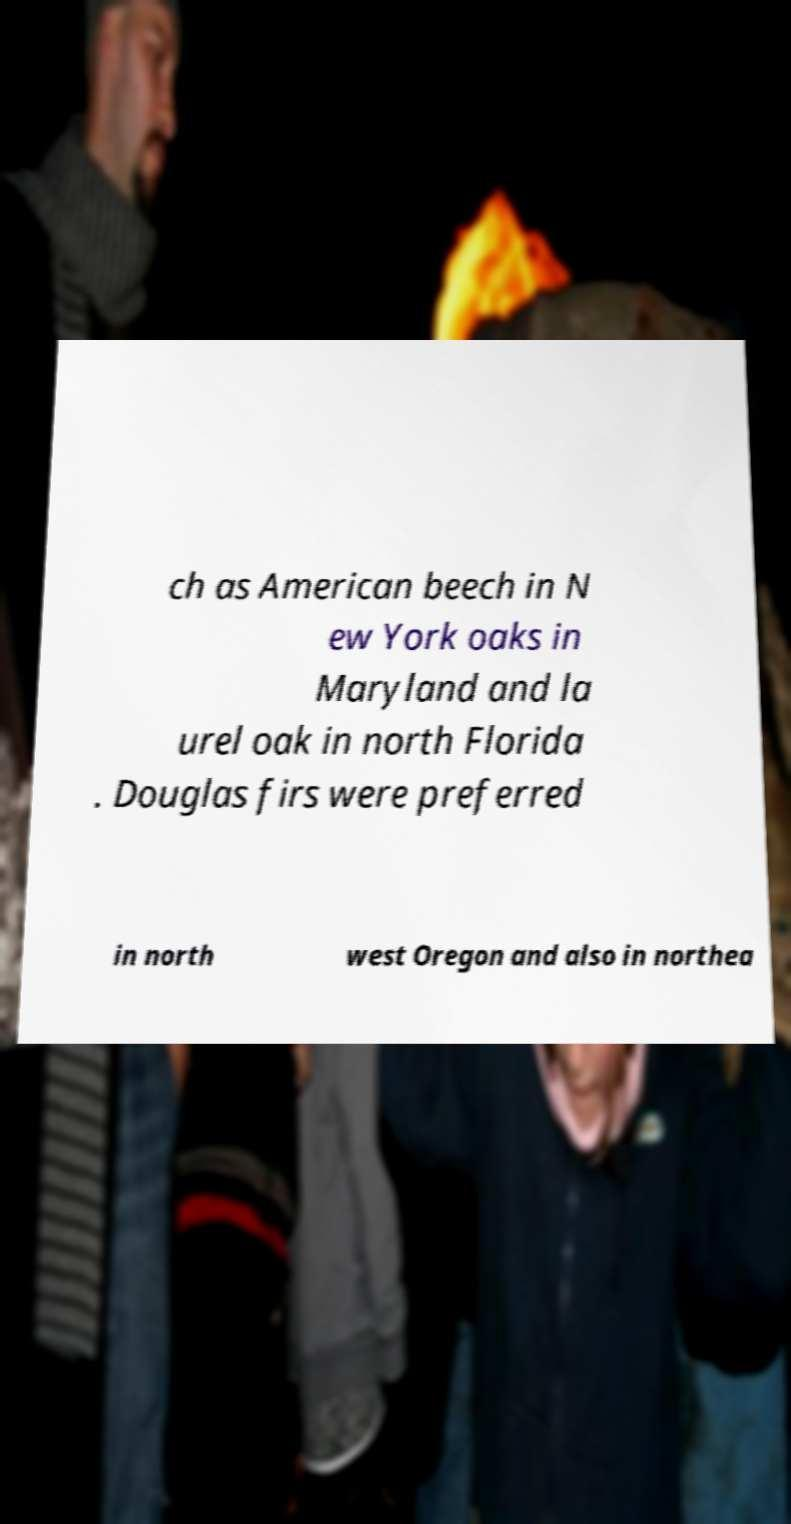There's text embedded in this image that I need extracted. Can you transcribe it verbatim? ch as American beech in N ew York oaks in Maryland and la urel oak in north Florida . Douglas firs were preferred in north west Oregon and also in northea 